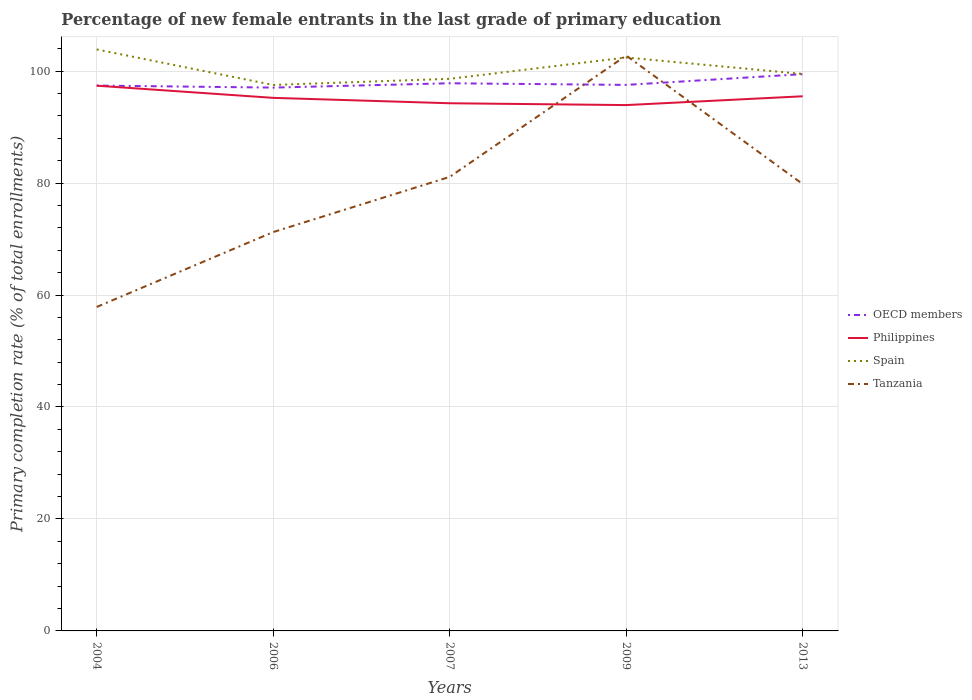Across all years, what is the maximum percentage of new female entrants in Tanzania?
Your response must be concise. 57.87. In which year was the percentage of new female entrants in Tanzania maximum?
Provide a succinct answer. 2004. What is the total percentage of new female entrants in Spain in the graph?
Provide a succinct answer. -4.91. What is the difference between the highest and the second highest percentage of new female entrants in OECD members?
Offer a terse response. 2.41. How many years are there in the graph?
Your response must be concise. 5. Are the values on the major ticks of Y-axis written in scientific E-notation?
Make the answer very short. No. Does the graph contain any zero values?
Offer a very short reply. No. What is the title of the graph?
Make the answer very short. Percentage of new female entrants in the last grade of primary education. Does "Canada" appear as one of the legend labels in the graph?
Your answer should be compact. No. What is the label or title of the Y-axis?
Keep it short and to the point. Primary completion rate (% of total enrollments). What is the Primary completion rate (% of total enrollments) in OECD members in 2004?
Keep it short and to the point. 97.42. What is the Primary completion rate (% of total enrollments) of Philippines in 2004?
Give a very brief answer. 97.39. What is the Primary completion rate (% of total enrollments) of Spain in 2004?
Make the answer very short. 103.87. What is the Primary completion rate (% of total enrollments) of Tanzania in 2004?
Make the answer very short. 57.87. What is the Primary completion rate (% of total enrollments) of OECD members in 2006?
Make the answer very short. 97.05. What is the Primary completion rate (% of total enrollments) in Philippines in 2006?
Offer a terse response. 95.22. What is the Primary completion rate (% of total enrollments) in Spain in 2006?
Offer a very short reply. 97.52. What is the Primary completion rate (% of total enrollments) of Tanzania in 2006?
Keep it short and to the point. 71.25. What is the Primary completion rate (% of total enrollments) of OECD members in 2007?
Provide a short and direct response. 97.83. What is the Primary completion rate (% of total enrollments) of Philippines in 2007?
Your answer should be compact. 94.26. What is the Primary completion rate (% of total enrollments) in Spain in 2007?
Offer a very short reply. 98.62. What is the Primary completion rate (% of total enrollments) in Tanzania in 2007?
Provide a short and direct response. 81.11. What is the Primary completion rate (% of total enrollments) in OECD members in 2009?
Provide a succinct answer. 97.54. What is the Primary completion rate (% of total enrollments) in Philippines in 2009?
Give a very brief answer. 93.93. What is the Primary completion rate (% of total enrollments) of Spain in 2009?
Provide a succinct answer. 102.43. What is the Primary completion rate (% of total enrollments) in Tanzania in 2009?
Your response must be concise. 102.78. What is the Primary completion rate (% of total enrollments) in OECD members in 2013?
Give a very brief answer. 99.46. What is the Primary completion rate (% of total enrollments) in Philippines in 2013?
Make the answer very short. 95.5. What is the Primary completion rate (% of total enrollments) in Spain in 2013?
Make the answer very short. 99.49. What is the Primary completion rate (% of total enrollments) of Tanzania in 2013?
Offer a very short reply. 79.82. Across all years, what is the maximum Primary completion rate (% of total enrollments) in OECD members?
Ensure brevity in your answer.  99.46. Across all years, what is the maximum Primary completion rate (% of total enrollments) in Philippines?
Your answer should be very brief. 97.39. Across all years, what is the maximum Primary completion rate (% of total enrollments) in Spain?
Keep it short and to the point. 103.87. Across all years, what is the maximum Primary completion rate (% of total enrollments) in Tanzania?
Your response must be concise. 102.78. Across all years, what is the minimum Primary completion rate (% of total enrollments) in OECD members?
Offer a very short reply. 97.05. Across all years, what is the minimum Primary completion rate (% of total enrollments) of Philippines?
Offer a terse response. 93.93. Across all years, what is the minimum Primary completion rate (% of total enrollments) of Spain?
Offer a terse response. 97.52. Across all years, what is the minimum Primary completion rate (% of total enrollments) of Tanzania?
Provide a short and direct response. 57.87. What is the total Primary completion rate (% of total enrollments) of OECD members in the graph?
Your answer should be very brief. 489.29. What is the total Primary completion rate (% of total enrollments) of Philippines in the graph?
Keep it short and to the point. 476.3. What is the total Primary completion rate (% of total enrollments) of Spain in the graph?
Offer a terse response. 501.94. What is the total Primary completion rate (% of total enrollments) in Tanzania in the graph?
Ensure brevity in your answer.  392.82. What is the difference between the Primary completion rate (% of total enrollments) in OECD members in 2004 and that in 2006?
Offer a very short reply. 0.36. What is the difference between the Primary completion rate (% of total enrollments) in Philippines in 2004 and that in 2006?
Keep it short and to the point. 2.17. What is the difference between the Primary completion rate (% of total enrollments) of Spain in 2004 and that in 2006?
Keep it short and to the point. 6.35. What is the difference between the Primary completion rate (% of total enrollments) of Tanzania in 2004 and that in 2006?
Your answer should be compact. -13.38. What is the difference between the Primary completion rate (% of total enrollments) of OECD members in 2004 and that in 2007?
Provide a succinct answer. -0.41. What is the difference between the Primary completion rate (% of total enrollments) of Philippines in 2004 and that in 2007?
Keep it short and to the point. 3.14. What is the difference between the Primary completion rate (% of total enrollments) of Spain in 2004 and that in 2007?
Make the answer very short. 5.24. What is the difference between the Primary completion rate (% of total enrollments) in Tanzania in 2004 and that in 2007?
Keep it short and to the point. -23.24. What is the difference between the Primary completion rate (% of total enrollments) of OECD members in 2004 and that in 2009?
Provide a succinct answer. -0.12. What is the difference between the Primary completion rate (% of total enrollments) of Philippines in 2004 and that in 2009?
Ensure brevity in your answer.  3.46. What is the difference between the Primary completion rate (% of total enrollments) in Spain in 2004 and that in 2009?
Ensure brevity in your answer.  1.44. What is the difference between the Primary completion rate (% of total enrollments) of Tanzania in 2004 and that in 2009?
Give a very brief answer. -44.91. What is the difference between the Primary completion rate (% of total enrollments) of OECD members in 2004 and that in 2013?
Offer a very short reply. -2.04. What is the difference between the Primary completion rate (% of total enrollments) of Philippines in 2004 and that in 2013?
Make the answer very short. 1.89. What is the difference between the Primary completion rate (% of total enrollments) of Spain in 2004 and that in 2013?
Your answer should be very brief. 4.38. What is the difference between the Primary completion rate (% of total enrollments) in Tanzania in 2004 and that in 2013?
Offer a very short reply. -21.95. What is the difference between the Primary completion rate (% of total enrollments) of OECD members in 2006 and that in 2007?
Your response must be concise. -0.77. What is the difference between the Primary completion rate (% of total enrollments) of Philippines in 2006 and that in 2007?
Make the answer very short. 0.96. What is the difference between the Primary completion rate (% of total enrollments) of Spain in 2006 and that in 2007?
Offer a terse response. -1.1. What is the difference between the Primary completion rate (% of total enrollments) in Tanzania in 2006 and that in 2007?
Keep it short and to the point. -9.86. What is the difference between the Primary completion rate (% of total enrollments) in OECD members in 2006 and that in 2009?
Offer a very short reply. -0.48. What is the difference between the Primary completion rate (% of total enrollments) of Philippines in 2006 and that in 2009?
Your answer should be very brief. 1.29. What is the difference between the Primary completion rate (% of total enrollments) in Spain in 2006 and that in 2009?
Provide a short and direct response. -4.91. What is the difference between the Primary completion rate (% of total enrollments) of Tanzania in 2006 and that in 2009?
Your response must be concise. -31.53. What is the difference between the Primary completion rate (% of total enrollments) of OECD members in 2006 and that in 2013?
Offer a terse response. -2.41. What is the difference between the Primary completion rate (% of total enrollments) in Philippines in 2006 and that in 2013?
Your response must be concise. -0.28. What is the difference between the Primary completion rate (% of total enrollments) in Spain in 2006 and that in 2013?
Offer a terse response. -1.97. What is the difference between the Primary completion rate (% of total enrollments) in Tanzania in 2006 and that in 2013?
Your answer should be very brief. -8.58. What is the difference between the Primary completion rate (% of total enrollments) of OECD members in 2007 and that in 2009?
Provide a short and direct response. 0.29. What is the difference between the Primary completion rate (% of total enrollments) in Philippines in 2007 and that in 2009?
Provide a short and direct response. 0.33. What is the difference between the Primary completion rate (% of total enrollments) in Spain in 2007 and that in 2009?
Ensure brevity in your answer.  -3.81. What is the difference between the Primary completion rate (% of total enrollments) in Tanzania in 2007 and that in 2009?
Offer a very short reply. -21.67. What is the difference between the Primary completion rate (% of total enrollments) in OECD members in 2007 and that in 2013?
Your response must be concise. -1.63. What is the difference between the Primary completion rate (% of total enrollments) of Philippines in 2007 and that in 2013?
Ensure brevity in your answer.  -1.24. What is the difference between the Primary completion rate (% of total enrollments) of Spain in 2007 and that in 2013?
Offer a very short reply. -0.87. What is the difference between the Primary completion rate (% of total enrollments) of Tanzania in 2007 and that in 2013?
Your answer should be compact. 1.29. What is the difference between the Primary completion rate (% of total enrollments) in OECD members in 2009 and that in 2013?
Your answer should be compact. -1.92. What is the difference between the Primary completion rate (% of total enrollments) of Philippines in 2009 and that in 2013?
Ensure brevity in your answer.  -1.57. What is the difference between the Primary completion rate (% of total enrollments) of Spain in 2009 and that in 2013?
Offer a very short reply. 2.94. What is the difference between the Primary completion rate (% of total enrollments) of Tanzania in 2009 and that in 2013?
Provide a succinct answer. 22.96. What is the difference between the Primary completion rate (% of total enrollments) in OECD members in 2004 and the Primary completion rate (% of total enrollments) in Philippines in 2006?
Your response must be concise. 2.19. What is the difference between the Primary completion rate (% of total enrollments) of OECD members in 2004 and the Primary completion rate (% of total enrollments) of Spain in 2006?
Offer a terse response. -0.11. What is the difference between the Primary completion rate (% of total enrollments) in OECD members in 2004 and the Primary completion rate (% of total enrollments) in Tanzania in 2006?
Your response must be concise. 26.17. What is the difference between the Primary completion rate (% of total enrollments) of Philippines in 2004 and the Primary completion rate (% of total enrollments) of Spain in 2006?
Your answer should be very brief. -0.13. What is the difference between the Primary completion rate (% of total enrollments) of Philippines in 2004 and the Primary completion rate (% of total enrollments) of Tanzania in 2006?
Your response must be concise. 26.15. What is the difference between the Primary completion rate (% of total enrollments) in Spain in 2004 and the Primary completion rate (% of total enrollments) in Tanzania in 2006?
Give a very brief answer. 32.62. What is the difference between the Primary completion rate (% of total enrollments) of OECD members in 2004 and the Primary completion rate (% of total enrollments) of Philippines in 2007?
Your response must be concise. 3.16. What is the difference between the Primary completion rate (% of total enrollments) in OECD members in 2004 and the Primary completion rate (% of total enrollments) in Spain in 2007?
Your answer should be very brief. -1.21. What is the difference between the Primary completion rate (% of total enrollments) of OECD members in 2004 and the Primary completion rate (% of total enrollments) of Tanzania in 2007?
Your answer should be compact. 16.31. What is the difference between the Primary completion rate (% of total enrollments) of Philippines in 2004 and the Primary completion rate (% of total enrollments) of Spain in 2007?
Make the answer very short. -1.23. What is the difference between the Primary completion rate (% of total enrollments) of Philippines in 2004 and the Primary completion rate (% of total enrollments) of Tanzania in 2007?
Ensure brevity in your answer.  16.29. What is the difference between the Primary completion rate (% of total enrollments) in Spain in 2004 and the Primary completion rate (% of total enrollments) in Tanzania in 2007?
Your answer should be compact. 22.76. What is the difference between the Primary completion rate (% of total enrollments) of OECD members in 2004 and the Primary completion rate (% of total enrollments) of Philippines in 2009?
Your answer should be compact. 3.49. What is the difference between the Primary completion rate (% of total enrollments) of OECD members in 2004 and the Primary completion rate (% of total enrollments) of Spain in 2009?
Offer a very short reply. -5.02. What is the difference between the Primary completion rate (% of total enrollments) of OECD members in 2004 and the Primary completion rate (% of total enrollments) of Tanzania in 2009?
Keep it short and to the point. -5.36. What is the difference between the Primary completion rate (% of total enrollments) in Philippines in 2004 and the Primary completion rate (% of total enrollments) in Spain in 2009?
Keep it short and to the point. -5.04. What is the difference between the Primary completion rate (% of total enrollments) of Philippines in 2004 and the Primary completion rate (% of total enrollments) of Tanzania in 2009?
Your answer should be compact. -5.39. What is the difference between the Primary completion rate (% of total enrollments) in Spain in 2004 and the Primary completion rate (% of total enrollments) in Tanzania in 2009?
Make the answer very short. 1.09. What is the difference between the Primary completion rate (% of total enrollments) of OECD members in 2004 and the Primary completion rate (% of total enrollments) of Philippines in 2013?
Keep it short and to the point. 1.91. What is the difference between the Primary completion rate (% of total enrollments) in OECD members in 2004 and the Primary completion rate (% of total enrollments) in Spain in 2013?
Offer a terse response. -2.08. What is the difference between the Primary completion rate (% of total enrollments) of OECD members in 2004 and the Primary completion rate (% of total enrollments) of Tanzania in 2013?
Keep it short and to the point. 17.59. What is the difference between the Primary completion rate (% of total enrollments) of Philippines in 2004 and the Primary completion rate (% of total enrollments) of Spain in 2013?
Offer a terse response. -2.1. What is the difference between the Primary completion rate (% of total enrollments) of Philippines in 2004 and the Primary completion rate (% of total enrollments) of Tanzania in 2013?
Keep it short and to the point. 17.57. What is the difference between the Primary completion rate (% of total enrollments) of Spain in 2004 and the Primary completion rate (% of total enrollments) of Tanzania in 2013?
Your answer should be very brief. 24.05. What is the difference between the Primary completion rate (% of total enrollments) in OECD members in 2006 and the Primary completion rate (% of total enrollments) in Philippines in 2007?
Your response must be concise. 2.8. What is the difference between the Primary completion rate (% of total enrollments) in OECD members in 2006 and the Primary completion rate (% of total enrollments) in Spain in 2007?
Keep it short and to the point. -1.57. What is the difference between the Primary completion rate (% of total enrollments) in OECD members in 2006 and the Primary completion rate (% of total enrollments) in Tanzania in 2007?
Give a very brief answer. 15.95. What is the difference between the Primary completion rate (% of total enrollments) of Philippines in 2006 and the Primary completion rate (% of total enrollments) of Spain in 2007?
Keep it short and to the point. -3.4. What is the difference between the Primary completion rate (% of total enrollments) of Philippines in 2006 and the Primary completion rate (% of total enrollments) of Tanzania in 2007?
Offer a terse response. 14.12. What is the difference between the Primary completion rate (% of total enrollments) of Spain in 2006 and the Primary completion rate (% of total enrollments) of Tanzania in 2007?
Provide a succinct answer. 16.42. What is the difference between the Primary completion rate (% of total enrollments) in OECD members in 2006 and the Primary completion rate (% of total enrollments) in Philippines in 2009?
Provide a succinct answer. 3.12. What is the difference between the Primary completion rate (% of total enrollments) of OECD members in 2006 and the Primary completion rate (% of total enrollments) of Spain in 2009?
Your answer should be compact. -5.38. What is the difference between the Primary completion rate (% of total enrollments) in OECD members in 2006 and the Primary completion rate (% of total enrollments) in Tanzania in 2009?
Your answer should be very brief. -5.73. What is the difference between the Primary completion rate (% of total enrollments) of Philippines in 2006 and the Primary completion rate (% of total enrollments) of Spain in 2009?
Provide a succinct answer. -7.21. What is the difference between the Primary completion rate (% of total enrollments) in Philippines in 2006 and the Primary completion rate (% of total enrollments) in Tanzania in 2009?
Your answer should be compact. -7.56. What is the difference between the Primary completion rate (% of total enrollments) of Spain in 2006 and the Primary completion rate (% of total enrollments) of Tanzania in 2009?
Offer a terse response. -5.26. What is the difference between the Primary completion rate (% of total enrollments) of OECD members in 2006 and the Primary completion rate (% of total enrollments) of Philippines in 2013?
Give a very brief answer. 1.55. What is the difference between the Primary completion rate (% of total enrollments) in OECD members in 2006 and the Primary completion rate (% of total enrollments) in Spain in 2013?
Provide a short and direct response. -2.44. What is the difference between the Primary completion rate (% of total enrollments) in OECD members in 2006 and the Primary completion rate (% of total enrollments) in Tanzania in 2013?
Offer a very short reply. 17.23. What is the difference between the Primary completion rate (% of total enrollments) of Philippines in 2006 and the Primary completion rate (% of total enrollments) of Spain in 2013?
Your response must be concise. -4.27. What is the difference between the Primary completion rate (% of total enrollments) in Philippines in 2006 and the Primary completion rate (% of total enrollments) in Tanzania in 2013?
Keep it short and to the point. 15.4. What is the difference between the Primary completion rate (% of total enrollments) in Spain in 2006 and the Primary completion rate (% of total enrollments) in Tanzania in 2013?
Offer a terse response. 17.7. What is the difference between the Primary completion rate (% of total enrollments) of OECD members in 2007 and the Primary completion rate (% of total enrollments) of Philippines in 2009?
Provide a succinct answer. 3.9. What is the difference between the Primary completion rate (% of total enrollments) in OECD members in 2007 and the Primary completion rate (% of total enrollments) in Spain in 2009?
Your answer should be very brief. -4.61. What is the difference between the Primary completion rate (% of total enrollments) of OECD members in 2007 and the Primary completion rate (% of total enrollments) of Tanzania in 2009?
Offer a very short reply. -4.95. What is the difference between the Primary completion rate (% of total enrollments) in Philippines in 2007 and the Primary completion rate (% of total enrollments) in Spain in 2009?
Provide a short and direct response. -8.17. What is the difference between the Primary completion rate (% of total enrollments) of Philippines in 2007 and the Primary completion rate (% of total enrollments) of Tanzania in 2009?
Your answer should be very brief. -8.52. What is the difference between the Primary completion rate (% of total enrollments) of Spain in 2007 and the Primary completion rate (% of total enrollments) of Tanzania in 2009?
Offer a very short reply. -4.15. What is the difference between the Primary completion rate (% of total enrollments) in OECD members in 2007 and the Primary completion rate (% of total enrollments) in Philippines in 2013?
Provide a succinct answer. 2.33. What is the difference between the Primary completion rate (% of total enrollments) in OECD members in 2007 and the Primary completion rate (% of total enrollments) in Spain in 2013?
Provide a succinct answer. -1.67. What is the difference between the Primary completion rate (% of total enrollments) in OECD members in 2007 and the Primary completion rate (% of total enrollments) in Tanzania in 2013?
Provide a short and direct response. 18.01. What is the difference between the Primary completion rate (% of total enrollments) of Philippines in 2007 and the Primary completion rate (% of total enrollments) of Spain in 2013?
Give a very brief answer. -5.23. What is the difference between the Primary completion rate (% of total enrollments) in Philippines in 2007 and the Primary completion rate (% of total enrollments) in Tanzania in 2013?
Your response must be concise. 14.44. What is the difference between the Primary completion rate (% of total enrollments) in Spain in 2007 and the Primary completion rate (% of total enrollments) in Tanzania in 2013?
Offer a very short reply. 18.8. What is the difference between the Primary completion rate (% of total enrollments) of OECD members in 2009 and the Primary completion rate (% of total enrollments) of Philippines in 2013?
Ensure brevity in your answer.  2.03. What is the difference between the Primary completion rate (% of total enrollments) in OECD members in 2009 and the Primary completion rate (% of total enrollments) in Spain in 2013?
Offer a terse response. -1.96. What is the difference between the Primary completion rate (% of total enrollments) of OECD members in 2009 and the Primary completion rate (% of total enrollments) of Tanzania in 2013?
Your response must be concise. 17.71. What is the difference between the Primary completion rate (% of total enrollments) in Philippines in 2009 and the Primary completion rate (% of total enrollments) in Spain in 2013?
Your answer should be compact. -5.56. What is the difference between the Primary completion rate (% of total enrollments) of Philippines in 2009 and the Primary completion rate (% of total enrollments) of Tanzania in 2013?
Your response must be concise. 14.11. What is the difference between the Primary completion rate (% of total enrollments) of Spain in 2009 and the Primary completion rate (% of total enrollments) of Tanzania in 2013?
Ensure brevity in your answer.  22.61. What is the average Primary completion rate (% of total enrollments) in OECD members per year?
Your response must be concise. 97.86. What is the average Primary completion rate (% of total enrollments) in Philippines per year?
Your answer should be compact. 95.26. What is the average Primary completion rate (% of total enrollments) of Spain per year?
Ensure brevity in your answer.  100.39. What is the average Primary completion rate (% of total enrollments) in Tanzania per year?
Provide a succinct answer. 78.56. In the year 2004, what is the difference between the Primary completion rate (% of total enrollments) in OECD members and Primary completion rate (% of total enrollments) in Philippines?
Your response must be concise. 0.02. In the year 2004, what is the difference between the Primary completion rate (% of total enrollments) in OECD members and Primary completion rate (% of total enrollments) in Spain?
Your answer should be very brief. -6.45. In the year 2004, what is the difference between the Primary completion rate (% of total enrollments) of OECD members and Primary completion rate (% of total enrollments) of Tanzania?
Offer a terse response. 39.55. In the year 2004, what is the difference between the Primary completion rate (% of total enrollments) of Philippines and Primary completion rate (% of total enrollments) of Spain?
Offer a very short reply. -6.47. In the year 2004, what is the difference between the Primary completion rate (% of total enrollments) of Philippines and Primary completion rate (% of total enrollments) of Tanzania?
Keep it short and to the point. 39.53. In the year 2004, what is the difference between the Primary completion rate (% of total enrollments) in Spain and Primary completion rate (% of total enrollments) in Tanzania?
Your answer should be compact. 46. In the year 2006, what is the difference between the Primary completion rate (% of total enrollments) of OECD members and Primary completion rate (% of total enrollments) of Philippines?
Offer a terse response. 1.83. In the year 2006, what is the difference between the Primary completion rate (% of total enrollments) in OECD members and Primary completion rate (% of total enrollments) in Spain?
Provide a short and direct response. -0.47. In the year 2006, what is the difference between the Primary completion rate (% of total enrollments) in OECD members and Primary completion rate (% of total enrollments) in Tanzania?
Give a very brief answer. 25.81. In the year 2006, what is the difference between the Primary completion rate (% of total enrollments) of Philippines and Primary completion rate (% of total enrollments) of Spain?
Give a very brief answer. -2.3. In the year 2006, what is the difference between the Primary completion rate (% of total enrollments) in Philippines and Primary completion rate (% of total enrollments) in Tanzania?
Your answer should be compact. 23.98. In the year 2006, what is the difference between the Primary completion rate (% of total enrollments) in Spain and Primary completion rate (% of total enrollments) in Tanzania?
Offer a terse response. 26.28. In the year 2007, what is the difference between the Primary completion rate (% of total enrollments) in OECD members and Primary completion rate (% of total enrollments) in Philippines?
Your answer should be compact. 3.57. In the year 2007, what is the difference between the Primary completion rate (% of total enrollments) of OECD members and Primary completion rate (% of total enrollments) of Spain?
Offer a terse response. -0.8. In the year 2007, what is the difference between the Primary completion rate (% of total enrollments) of OECD members and Primary completion rate (% of total enrollments) of Tanzania?
Ensure brevity in your answer.  16.72. In the year 2007, what is the difference between the Primary completion rate (% of total enrollments) of Philippines and Primary completion rate (% of total enrollments) of Spain?
Offer a very short reply. -4.37. In the year 2007, what is the difference between the Primary completion rate (% of total enrollments) in Philippines and Primary completion rate (% of total enrollments) in Tanzania?
Your answer should be very brief. 13.15. In the year 2007, what is the difference between the Primary completion rate (% of total enrollments) of Spain and Primary completion rate (% of total enrollments) of Tanzania?
Make the answer very short. 17.52. In the year 2009, what is the difference between the Primary completion rate (% of total enrollments) in OECD members and Primary completion rate (% of total enrollments) in Philippines?
Your response must be concise. 3.61. In the year 2009, what is the difference between the Primary completion rate (% of total enrollments) in OECD members and Primary completion rate (% of total enrollments) in Spain?
Offer a very short reply. -4.9. In the year 2009, what is the difference between the Primary completion rate (% of total enrollments) in OECD members and Primary completion rate (% of total enrollments) in Tanzania?
Your answer should be compact. -5.24. In the year 2009, what is the difference between the Primary completion rate (% of total enrollments) of Philippines and Primary completion rate (% of total enrollments) of Spain?
Make the answer very short. -8.5. In the year 2009, what is the difference between the Primary completion rate (% of total enrollments) of Philippines and Primary completion rate (% of total enrollments) of Tanzania?
Your answer should be compact. -8.85. In the year 2009, what is the difference between the Primary completion rate (% of total enrollments) in Spain and Primary completion rate (% of total enrollments) in Tanzania?
Provide a succinct answer. -0.35. In the year 2013, what is the difference between the Primary completion rate (% of total enrollments) in OECD members and Primary completion rate (% of total enrollments) in Philippines?
Your answer should be very brief. 3.96. In the year 2013, what is the difference between the Primary completion rate (% of total enrollments) in OECD members and Primary completion rate (% of total enrollments) in Spain?
Make the answer very short. -0.03. In the year 2013, what is the difference between the Primary completion rate (% of total enrollments) of OECD members and Primary completion rate (% of total enrollments) of Tanzania?
Provide a short and direct response. 19.64. In the year 2013, what is the difference between the Primary completion rate (% of total enrollments) of Philippines and Primary completion rate (% of total enrollments) of Spain?
Your response must be concise. -3.99. In the year 2013, what is the difference between the Primary completion rate (% of total enrollments) in Philippines and Primary completion rate (% of total enrollments) in Tanzania?
Ensure brevity in your answer.  15.68. In the year 2013, what is the difference between the Primary completion rate (% of total enrollments) of Spain and Primary completion rate (% of total enrollments) of Tanzania?
Offer a terse response. 19.67. What is the ratio of the Primary completion rate (% of total enrollments) of Philippines in 2004 to that in 2006?
Offer a terse response. 1.02. What is the ratio of the Primary completion rate (% of total enrollments) in Spain in 2004 to that in 2006?
Keep it short and to the point. 1.07. What is the ratio of the Primary completion rate (% of total enrollments) in Tanzania in 2004 to that in 2006?
Give a very brief answer. 0.81. What is the ratio of the Primary completion rate (% of total enrollments) in OECD members in 2004 to that in 2007?
Offer a terse response. 1. What is the ratio of the Primary completion rate (% of total enrollments) in Philippines in 2004 to that in 2007?
Provide a succinct answer. 1.03. What is the ratio of the Primary completion rate (% of total enrollments) in Spain in 2004 to that in 2007?
Make the answer very short. 1.05. What is the ratio of the Primary completion rate (% of total enrollments) in Tanzania in 2004 to that in 2007?
Ensure brevity in your answer.  0.71. What is the ratio of the Primary completion rate (% of total enrollments) in OECD members in 2004 to that in 2009?
Provide a short and direct response. 1. What is the ratio of the Primary completion rate (% of total enrollments) of Philippines in 2004 to that in 2009?
Provide a succinct answer. 1.04. What is the ratio of the Primary completion rate (% of total enrollments) of Spain in 2004 to that in 2009?
Your response must be concise. 1.01. What is the ratio of the Primary completion rate (% of total enrollments) of Tanzania in 2004 to that in 2009?
Make the answer very short. 0.56. What is the ratio of the Primary completion rate (% of total enrollments) in OECD members in 2004 to that in 2013?
Offer a terse response. 0.98. What is the ratio of the Primary completion rate (% of total enrollments) in Philippines in 2004 to that in 2013?
Provide a succinct answer. 1.02. What is the ratio of the Primary completion rate (% of total enrollments) in Spain in 2004 to that in 2013?
Offer a terse response. 1.04. What is the ratio of the Primary completion rate (% of total enrollments) in Tanzania in 2004 to that in 2013?
Offer a terse response. 0.72. What is the ratio of the Primary completion rate (% of total enrollments) in OECD members in 2006 to that in 2007?
Your answer should be very brief. 0.99. What is the ratio of the Primary completion rate (% of total enrollments) in Philippines in 2006 to that in 2007?
Your answer should be compact. 1.01. What is the ratio of the Primary completion rate (% of total enrollments) in Tanzania in 2006 to that in 2007?
Make the answer very short. 0.88. What is the ratio of the Primary completion rate (% of total enrollments) of Philippines in 2006 to that in 2009?
Provide a short and direct response. 1.01. What is the ratio of the Primary completion rate (% of total enrollments) in Spain in 2006 to that in 2009?
Your answer should be very brief. 0.95. What is the ratio of the Primary completion rate (% of total enrollments) in Tanzania in 2006 to that in 2009?
Give a very brief answer. 0.69. What is the ratio of the Primary completion rate (% of total enrollments) in OECD members in 2006 to that in 2013?
Provide a succinct answer. 0.98. What is the ratio of the Primary completion rate (% of total enrollments) of Spain in 2006 to that in 2013?
Provide a succinct answer. 0.98. What is the ratio of the Primary completion rate (% of total enrollments) of Tanzania in 2006 to that in 2013?
Ensure brevity in your answer.  0.89. What is the ratio of the Primary completion rate (% of total enrollments) of Philippines in 2007 to that in 2009?
Give a very brief answer. 1. What is the ratio of the Primary completion rate (% of total enrollments) of Spain in 2007 to that in 2009?
Keep it short and to the point. 0.96. What is the ratio of the Primary completion rate (% of total enrollments) of Tanzania in 2007 to that in 2009?
Make the answer very short. 0.79. What is the ratio of the Primary completion rate (% of total enrollments) of OECD members in 2007 to that in 2013?
Provide a short and direct response. 0.98. What is the ratio of the Primary completion rate (% of total enrollments) of Philippines in 2007 to that in 2013?
Ensure brevity in your answer.  0.99. What is the ratio of the Primary completion rate (% of total enrollments) of Spain in 2007 to that in 2013?
Provide a succinct answer. 0.99. What is the ratio of the Primary completion rate (% of total enrollments) of Tanzania in 2007 to that in 2013?
Give a very brief answer. 1.02. What is the ratio of the Primary completion rate (% of total enrollments) in OECD members in 2009 to that in 2013?
Provide a succinct answer. 0.98. What is the ratio of the Primary completion rate (% of total enrollments) in Philippines in 2009 to that in 2013?
Make the answer very short. 0.98. What is the ratio of the Primary completion rate (% of total enrollments) of Spain in 2009 to that in 2013?
Ensure brevity in your answer.  1.03. What is the ratio of the Primary completion rate (% of total enrollments) in Tanzania in 2009 to that in 2013?
Ensure brevity in your answer.  1.29. What is the difference between the highest and the second highest Primary completion rate (% of total enrollments) of OECD members?
Your answer should be compact. 1.63. What is the difference between the highest and the second highest Primary completion rate (% of total enrollments) in Philippines?
Your answer should be very brief. 1.89. What is the difference between the highest and the second highest Primary completion rate (% of total enrollments) of Spain?
Offer a terse response. 1.44. What is the difference between the highest and the second highest Primary completion rate (% of total enrollments) in Tanzania?
Your answer should be very brief. 21.67. What is the difference between the highest and the lowest Primary completion rate (% of total enrollments) of OECD members?
Keep it short and to the point. 2.41. What is the difference between the highest and the lowest Primary completion rate (% of total enrollments) of Philippines?
Keep it short and to the point. 3.46. What is the difference between the highest and the lowest Primary completion rate (% of total enrollments) in Spain?
Your answer should be compact. 6.35. What is the difference between the highest and the lowest Primary completion rate (% of total enrollments) in Tanzania?
Your answer should be compact. 44.91. 